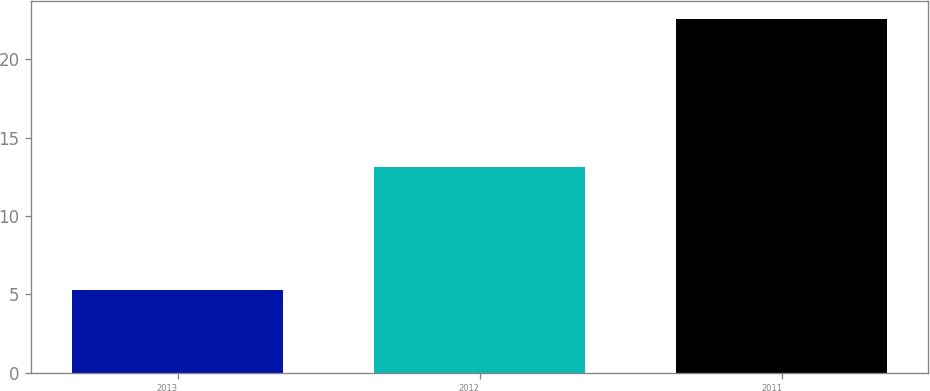<chart> <loc_0><loc_0><loc_500><loc_500><bar_chart><fcel>2013<fcel>2012<fcel>2011<nl><fcel>5.3<fcel>13.1<fcel>22.6<nl></chart> 